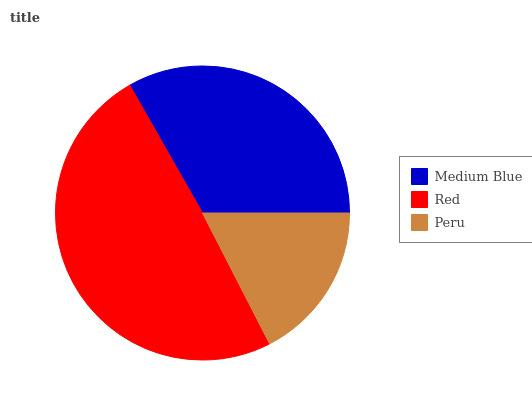Is Peru the minimum?
Answer yes or no. Yes. Is Red the maximum?
Answer yes or no. Yes. Is Red the minimum?
Answer yes or no. No. Is Peru the maximum?
Answer yes or no. No. Is Red greater than Peru?
Answer yes or no. Yes. Is Peru less than Red?
Answer yes or no. Yes. Is Peru greater than Red?
Answer yes or no. No. Is Red less than Peru?
Answer yes or no. No. Is Medium Blue the high median?
Answer yes or no. Yes. Is Medium Blue the low median?
Answer yes or no. Yes. Is Red the high median?
Answer yes or no. No. Is Peru the low median?
Answer yes or no. No. 